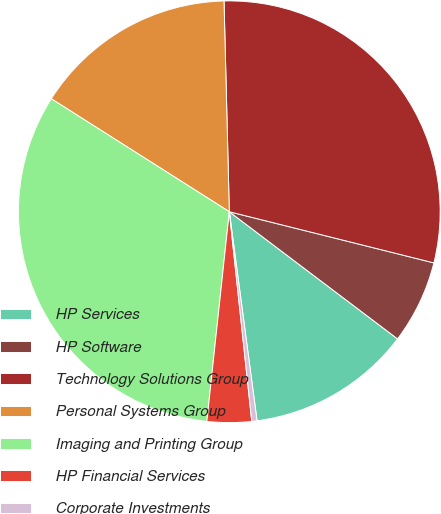<chart> <loc_0><loc_0><loc_500><loc_500><pie_chart><fcel>HP Services<fcel>HP Software<fcel>Technology Solutions Group<fcel>Personal Systems Group<fcel>Imaging and Printing Group<fcel>HP Financial Services<fcel>Corporate Investments<nl><fcel>12.6%<fcel>6.4%<fcel>29.3%<fcel>15.6%<fcel>32.3%<fcel>3.4%<fcel>0.4%<nl></chart> 